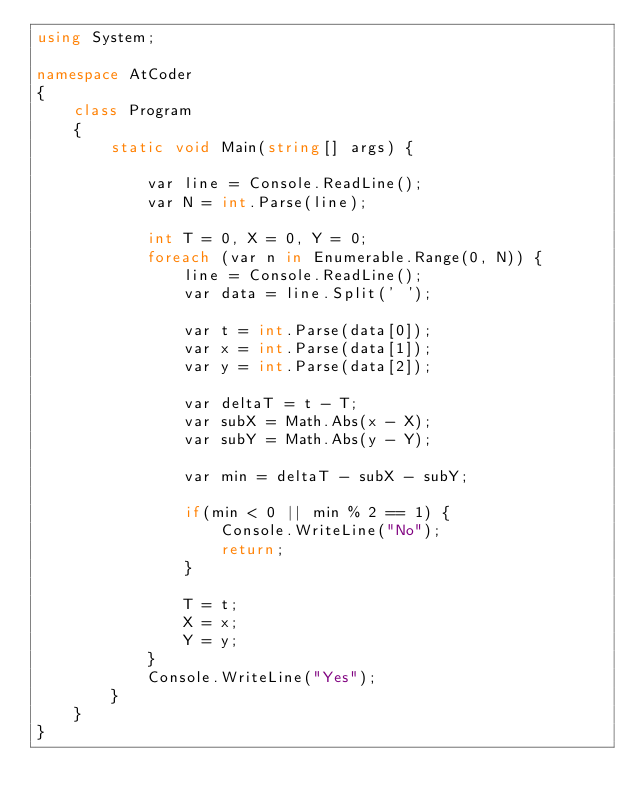Convert code to text. <code><loc_0><loc_0><loc_500><loc_500><_C#_>using System;

namespace AtCoder
{
    class Program
    {
        static void Main(string[] args) {

            var line = Console.ReadLine();
            var N = int.Parse(line);

            int T = 0, X = 0, Y = 0;
            foreach (var n in Enumerable.Range(0, N)) {
                line = Console.ReadLine();
                var data = line.Split(' ');

                var t = int.Parse(data[0]);
                var x = int.Parse(data[1]);
                var y = int.Parse(data[2]);

                var deltaT = t - T;
                var subX = Math.Abs(x - X);
                var subY = Math.Abs(y - Y);

                var min = deltaT - subX - subY;

                if(min < 0 || min % 2 == 1) {
                    Console.WriteLine("No");
                    return;
                }

                T = t;
                X = x;
                Y = y;
            }
            Console.WriteLine("Yes");
        }
    }
}
</code> 